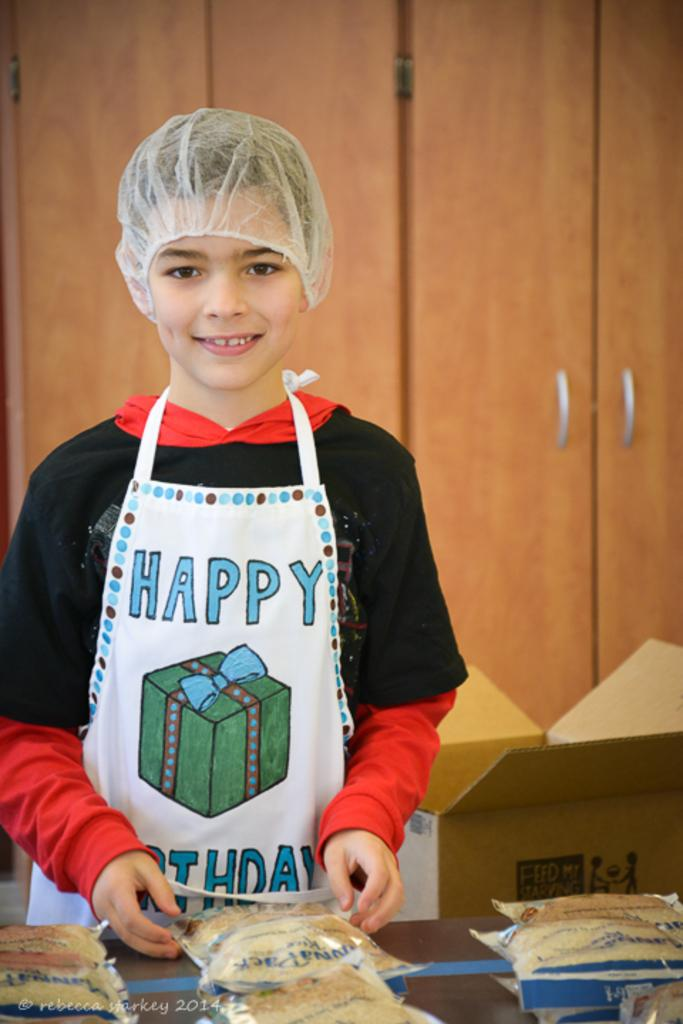Who is the main subject in the image? There is a boy in the image. What is the boy wearing? The boy is wearing an apron. What can be seen on the table in front of the boy? There are packets of food on the table in front of the boy. What type of material is used for the cupboards in the background? The cupboards in the background are made of wood. How many eyes can be seen on the thread in the image? There is no thread or eyes present in the image. What type of holiday is being celebrated in the image? There is no indication of a holiday being celebrated in the image. 